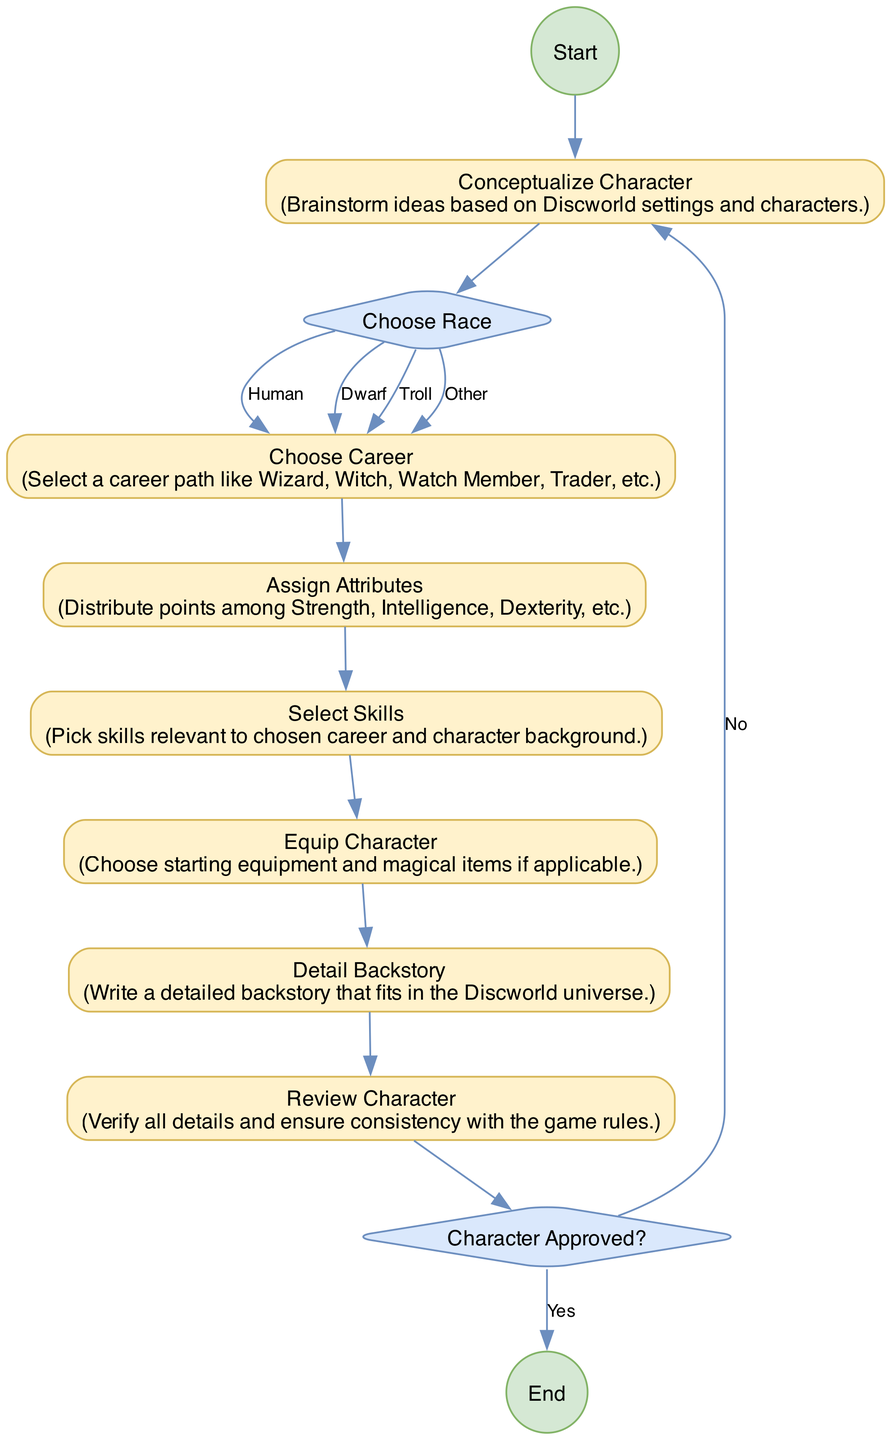What is the first activity in the diagram? The first activity is "Conceptualize Character," which comes immediately after the "Start" event. This is the first action taken in the character creation process according to the flow of the diagram.
Answer: Conceptualize Character How many total activities are presented in the diagram? The activities include "Conceptualize Character," "Choose Career," "Assign Attributes," "Select Skills," "Equip Character," "Detail Backstory," and "Review Character." Counting these gives a total of seven activities.
Answer: 7 What decision follows the "Review Character" activity? After the "Review Character" activity, the diagram moves to the "Character Approved?" decision node, where the player must determine if the character is approved to finalize the creation process.
Answer: Character Approved? How many options are available in the "Choose Race" decision? The "Choose Race" decision provides four options: Human, Dwarf, Troll, and Other. Each of these leads the player to the same next activity, "Choose Career." Thus, there are four distinct options.
Answer: 4 What happens if the answer to "Character Approved?" is no? If the answer to "Character Approved?" is "No," the flow returns to "Conceptualize Character," which indicates the player must rethink their character idea before proceeding again.
Answer: Return to Conceptualize Character Which activity comes immediately after "Equip Character"? The activity that immediately follows "Equip Character" in the diagram is "Detail Backstory." This step involves creating a narrative that fits the character within the Discworld universe.
Answer: Detail Backstory What is the final step in the character creation process as represented in this diagram? The final step in the process is the "End" event, which indicates that all character creation activities have been completed and the character is ready to play.
Answer: End How does one progress after "Choose Career"? Following "Choose Career," the next activity in the flow is "Assign Attributes." This indicates that once a career is selected, the player must then allocate their character's attributes.
Answer: Assign Attributes 